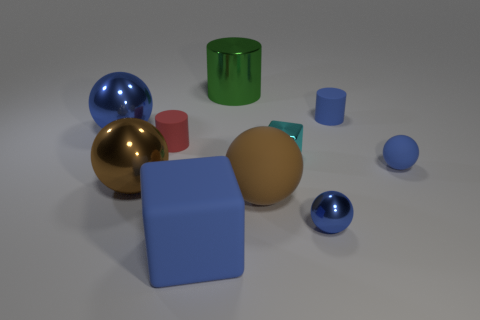Do the red matte cylinder and the cyan object have the same size?
Ensure brevity in your answer.  Yes. How many cylinders are small red metal objects or small metallic things?
Keep it short and to the point. 0. How many spheres are left of the small metal sphere and in front of the small cyan metal thing?
Offer a very short reply. 2. Do the red matte thing and the blue shiny sphere that is to the right of the big metal cylinder have the same size?
Provide a succinct answer. Yes. There is a matte object behind the blue sphere that is left of the brown rubber sphere; is there a tiny sphere in front of it?
Offer a very short reply. Yes. What material is the large thing behind the blue shiny ball behind the small cyan metallic cube?
Keep it short and to the point. Metal. There is a big thing that is in front of the large brown metal sphere and behind the big blue rubber thing; what material is it made of?
Make the answer very short. Rubber. Is there a big blue thing that has the same shape as the cyan metal object?
Offer a very short reply. Yes. There is a large brown ball that is to the right of the large blue matte block; is there a small blue sphere behind it?
Provide a short and direct response. Yes. What number of large green objects have the same material as the large green cylinder?
Your answer should be very brief. 0. 